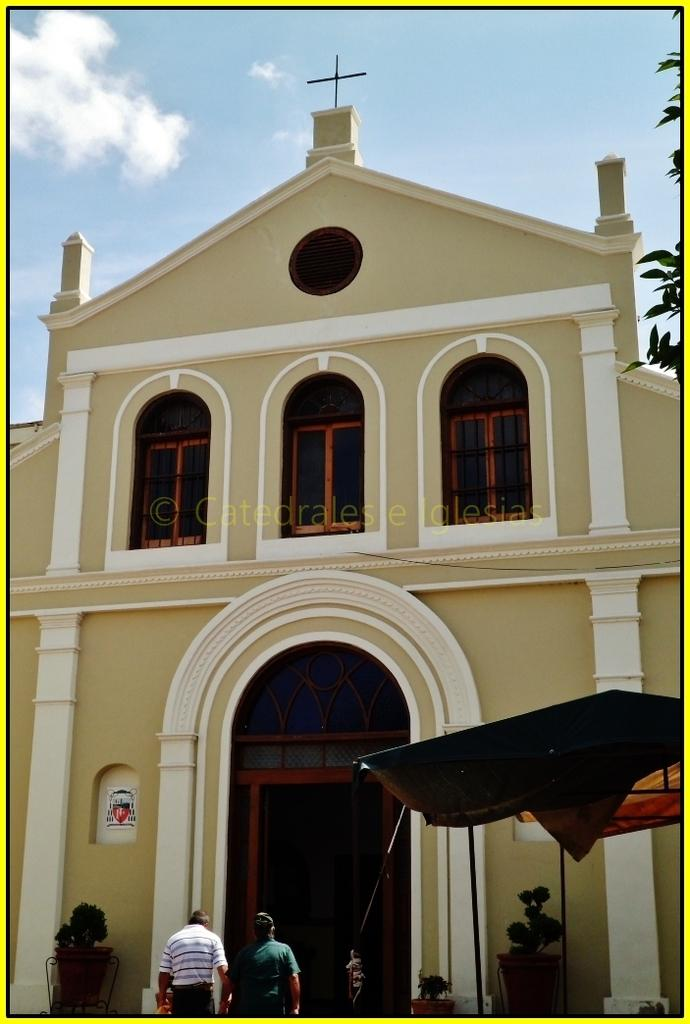What type of structure is present in the image? There is a building in the image. What feature can be observed on the building? The building has windows. Who or what else is visible in the image? There are people and flower pots in the image. What type of vegetation is present in the image? There are leaves in the image. What can be seen in the background of the image? The sky is visible in the image. How many kittens are playing with the corn in the image? There are no kittens or corn present in the image. 